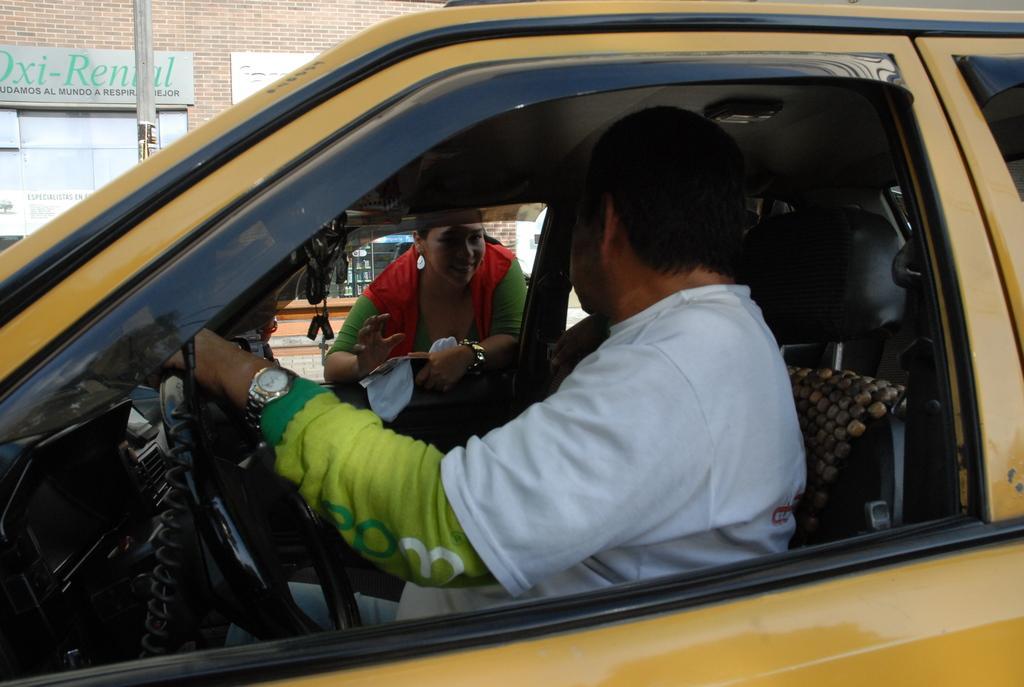How would you summarize this image in a sentence or two? In this image i can see a person sit on the car and woman stand in front of the car she wearing a green color skirt and on the right side i can see a wall ,on the wall i can see a board and there are some text written on the board. 